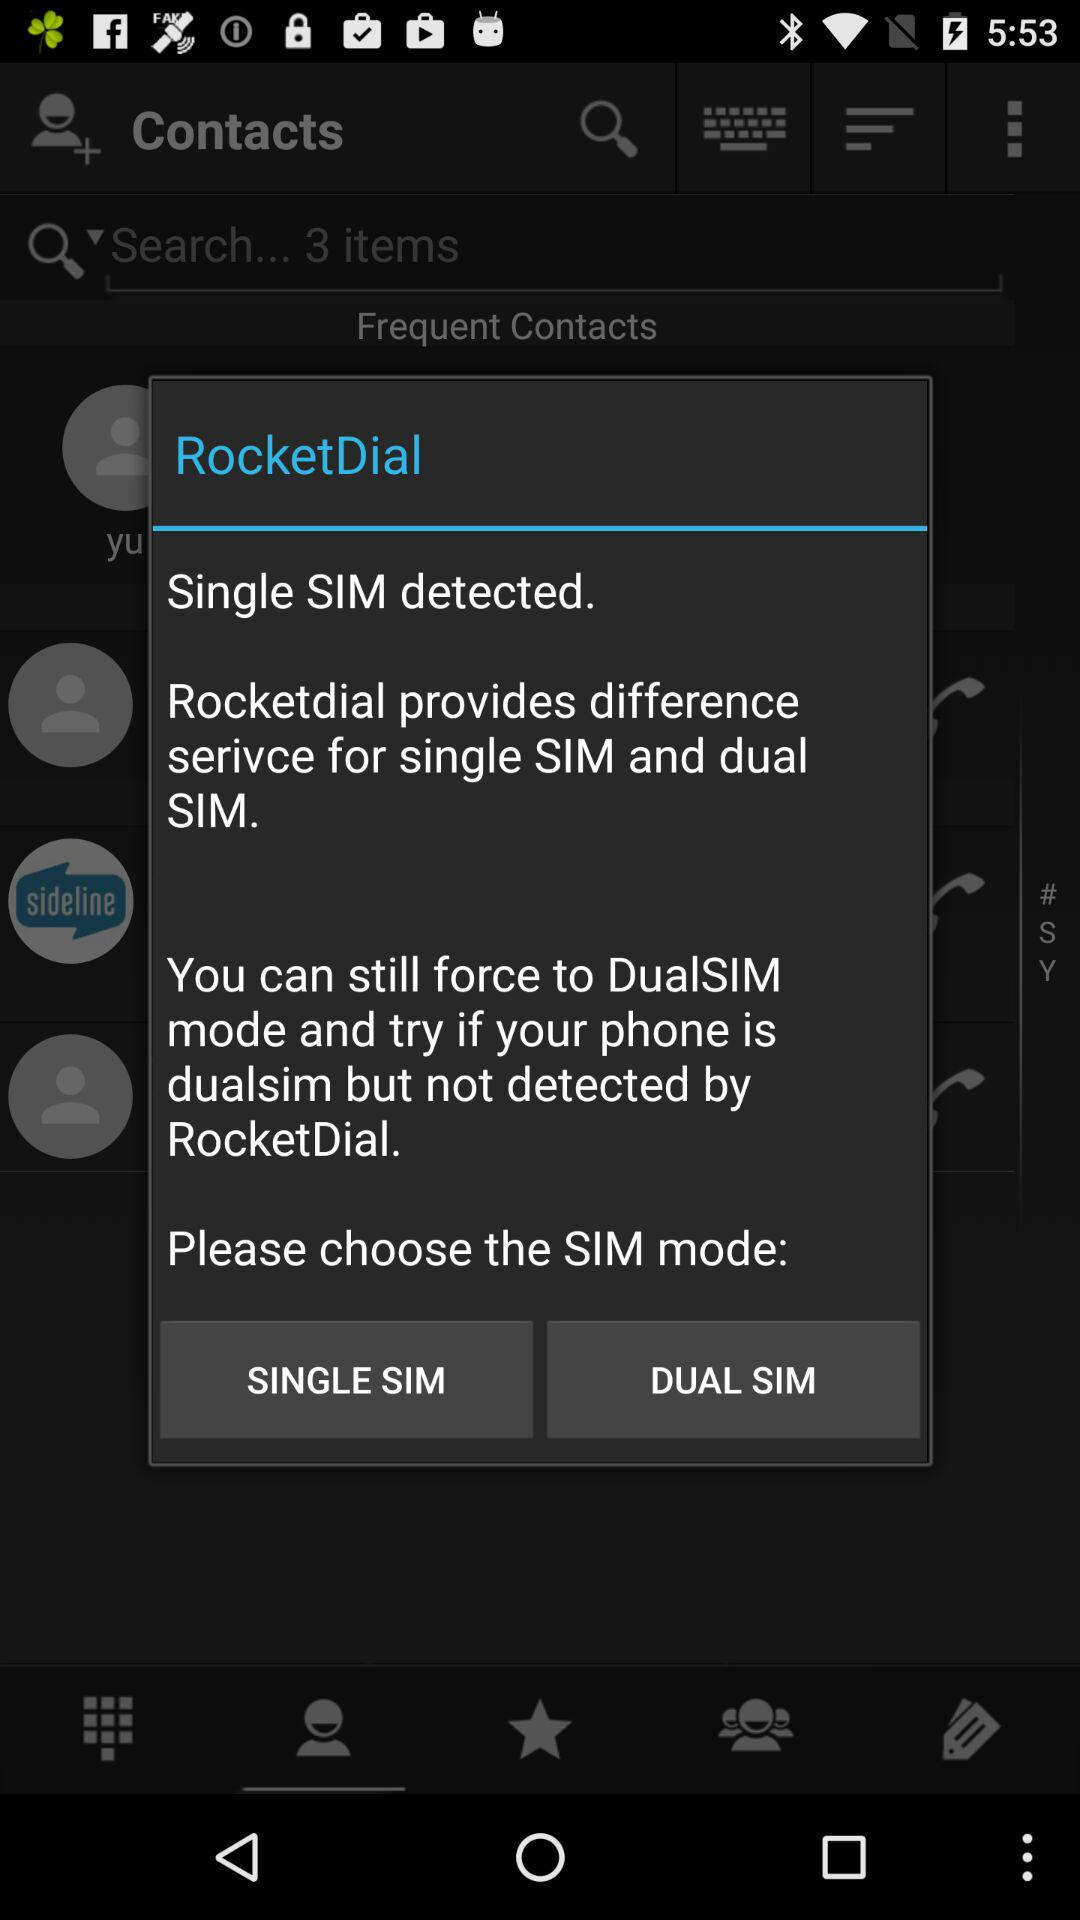What is the name of the application? The name of the application is "RocketDial". 